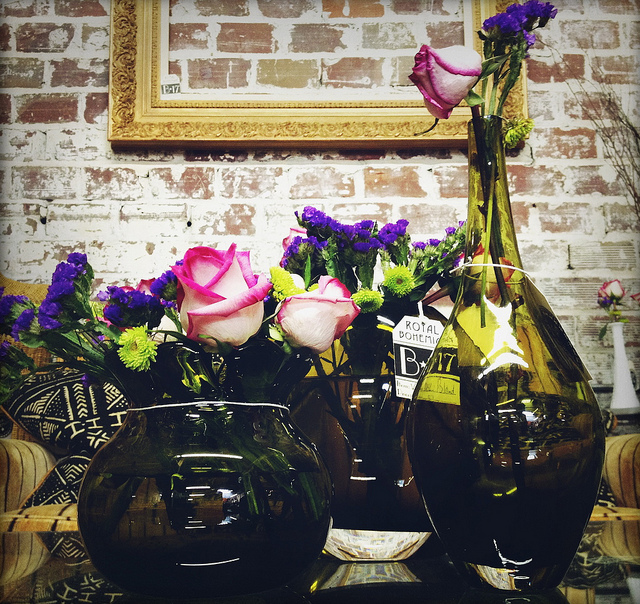Please transcribe the text in this image. ROTAL BOHEMI B 17 I H I I I T 